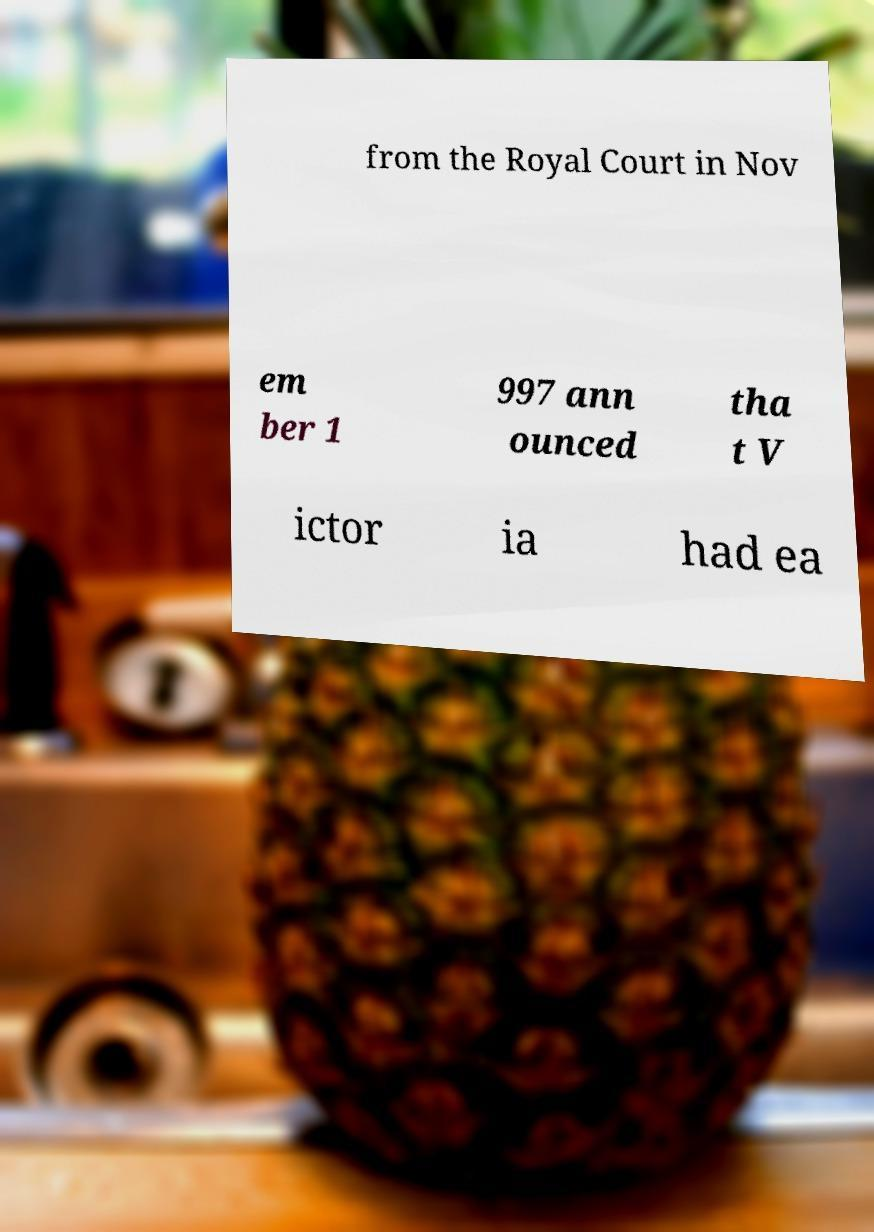Can you read and provide the text displayed in the image?This photo seems to have some interesting text. Can you extract and type it out for me? from the Royal Court in Nov em ber 1 997 ann ounced tha t V ictor ia had ea 